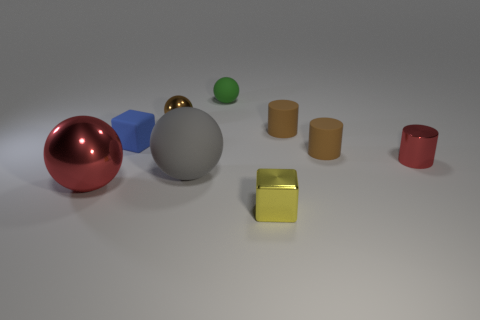Add 1 blue spheres. How many objects exist? 10 Subtract all cubes. How many objects are left? 7 Add 3 rubber objects. How many rubber objects are left? 8 Add 1 rubber objects. How many rubber objects exist? 6 Subtract 0 yellow balls. How many objects are left? 9 Subtract all large red metal balls. Subtract all red shiny spheres. How many objects are left? 7 